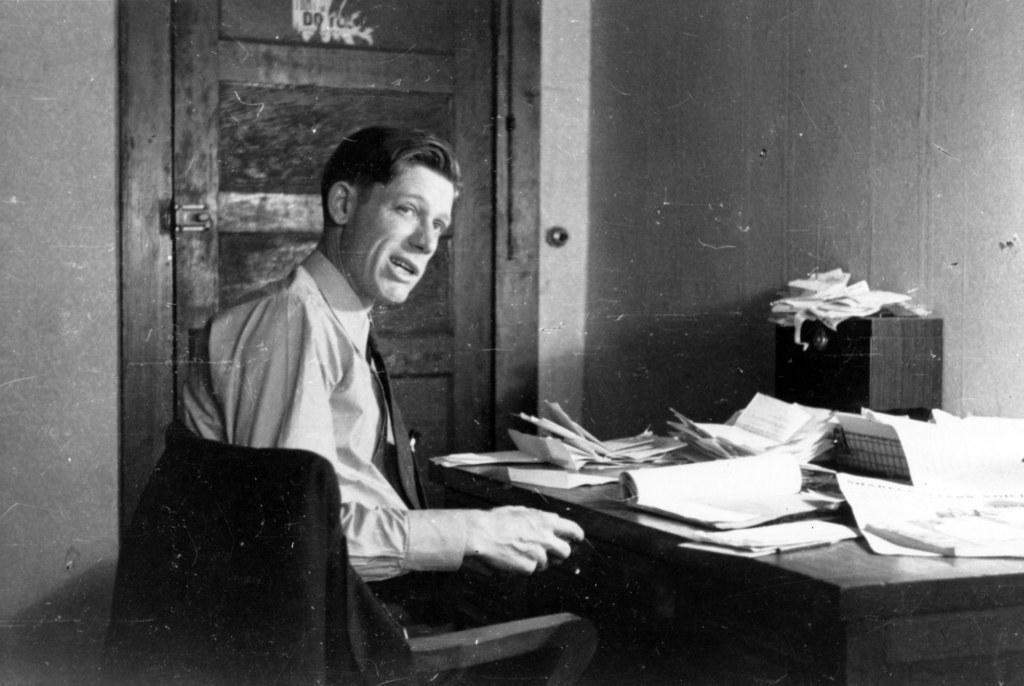Describe this image in one or two sentences. In this picture we can see a man is sitting on a chair in front of a table, there are some papers present on this table, on the right side we can see a wall, in the background there is a door, it is a black and white image. 